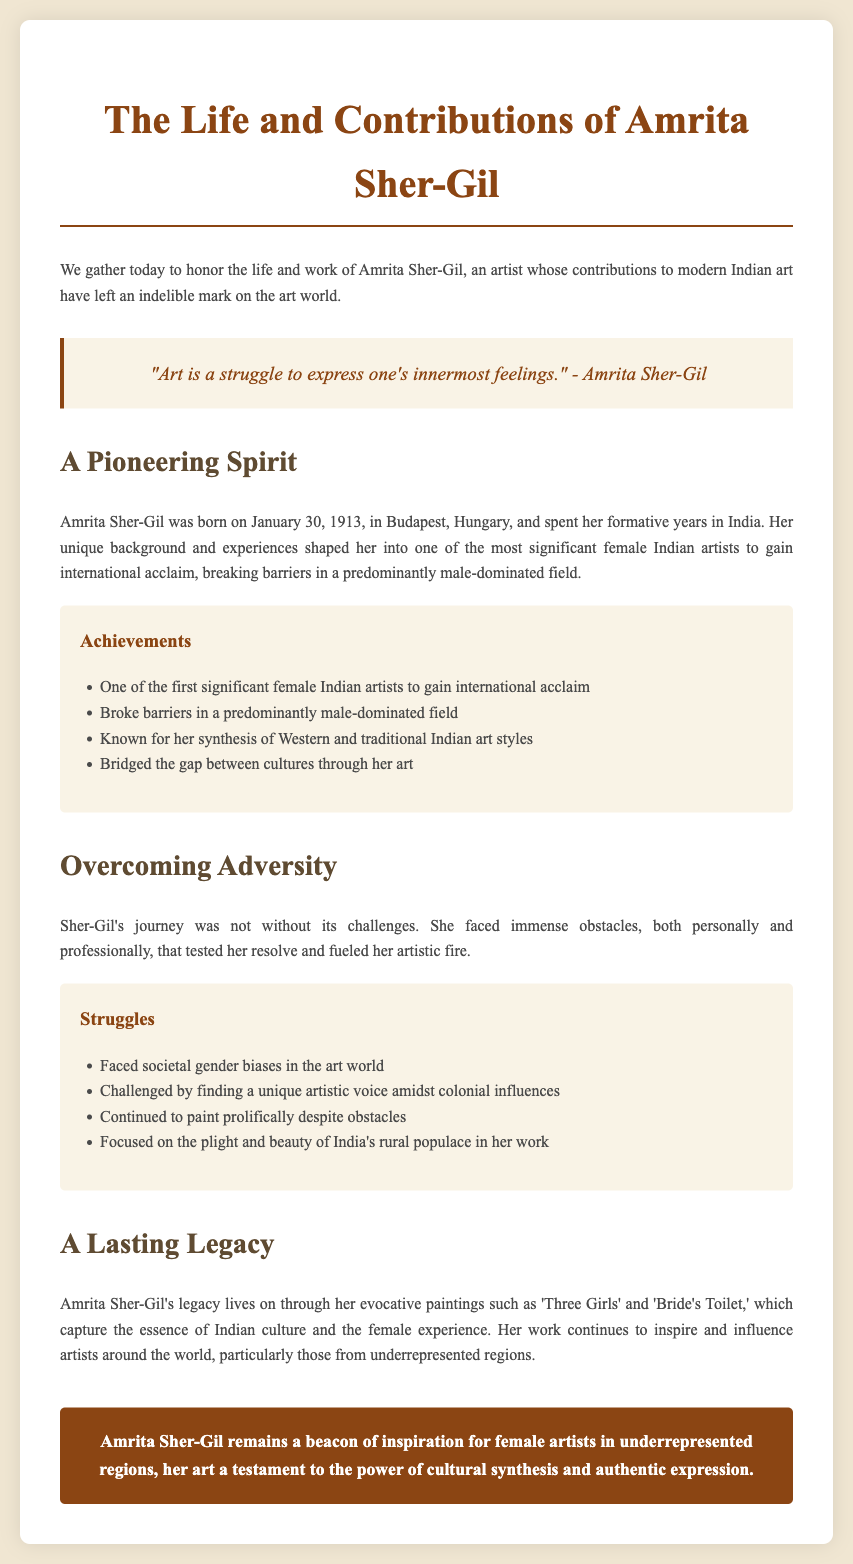What is the birth date of Amrita Sher-Gil? The document states that Amrita Sher-Gil was born on January 30, 1913.
Answer: January 30, 1913 What nationality did Amrita Sher-Gil belong to? The document mentions Amrita Sher-Gil as one of the significant female Indian artists.
Answer: Indian What is one of the notable works of Amrita Sher-Gil? The eulogy references her evocative paintings such as 'Three Girls' and 'Bride's Toilet.'
Answer: 'Three Girls' What impediments did Sher-Gil face in her career? The document states she faced societal gender biases and challenges in finding her artistic voice.
Answer: Gender biases How did Amrita Sher-Gil contribute to cultural synthesis? The text explains she is known for her synthesis of Western and traditional Indian art styles.
Answer: Synthesis of Western and traditional Indian art styles What role did her background play in her career? The eulogy indicates her unique background shaped her into a significant female Indian artist.
Answer: Unique background How did Sher-Gil’s work impact future artists? Her work continues to inspire and influence artists, particularly those from underrepresented regions.
Answer: Inspire and influence artists What did Amrita Sher-Gil focus on in her artwork? The document indicates she focused on the plight and beauty of India's rural populace.
Answer: India's rural populace 